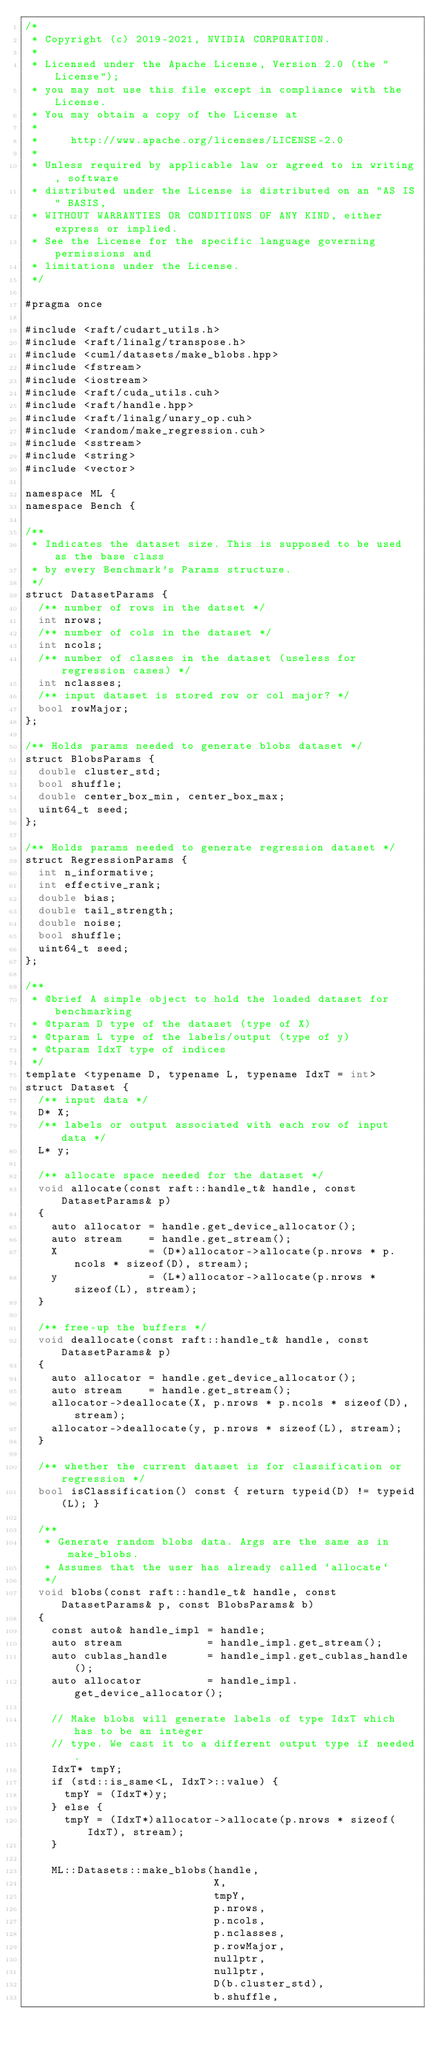Convert code to text. <code><loc_0><loc_0><loc_500><loc_500><_Cuda_>/*
 * Copyright (c) 2019-2021, NVIDIA CORPORATION.
 *
 * Licensed under the Apache License, Version 2.0 (the "License");
 * you may not use this file except in compliance with the License.
 * You may obtain a copy of the License at
 *
 *     http://www.apache.org/licenses/LICENSE-2.0
 *
 * Unless required by applicable law or agreed to in writing, software
 * distributed under the License is distributed on an "AS IS" BASIS,
 * WITHOUT WARRANTIES OR CONDITIONS OF ANY KIND, either express or implied.
 * See the License for the specific language governing permissions and
 * limitations under the License.
 */

#pragma once

#include <raft/cudart_utils.h>
#include <raft/linalg/transpose.h>
#include <cuml/datasets/make_blobs.hpp>
#include <fstream>
#include <iostream>
#include <raft/cuda_utils.cuh>
#include <raft/handle.hpp>
#include <raft/linalg/unary_op.cuh>
#include <random/make_regression.cuh>
#include <sstream>
#include <string>
#include <vector>

namespace ML {
namespace Bench {

/**
 * Indicates the dataset size. This is supposed to be used as the base class
 * by every Benchmark's Params structure.
 */
struct DatasetParams {
  /** number of rows in the datset */
  int nrows;
  /** number of cols in the dataset */
  int ncols;
  /** number of classes in the dataset (useless for regression cases) */
  int nclasses;
  /** input dataset is stored row or col major? */
  bool rowMajor;
};

/** Holds params needed to generate blobs dataset */
struct BlobsParams {
  double cluster_std;
  bool shuffle;
  double center_box_min, center_box_max;
  uint64_t seed;
};

/** Holds params needed to generate regression dataset */
struct RegressionParams {
  int n_informative;
  int effective_rank;
  double bias;
  double tail_strength;
  double noise;
  bool shuffle;
  uint64_t seed;
};

/**
 * @brief A simple object to hold the loaded dataset for benchmarking
 * @tparam D type of the dataset (type of X)
 * @tparam L type of the labels/output (type of y)
 * @tparam IdxT type of indices
 */
template <typename D, typename L, typename IdxT = int>
struct Dataset {
  /** input data */
  D* X;
  /** labels or output associated with each row of input data */
  L* y;

  /** allocate space needed for the dataset */
  void allocate(const raft::handle_t& handle, const DatasetParams& p)
  {
    auto allocator = handle.get_device_allocator();
    auto stream    = handle.get_stream();
    X              = (D*)allocator->allocate(p.nrows * p.ncols * sizeof(D), stream);
    y              = (L*)allocator->allocate(p.nrows * sizeof(L), stream);
  }

  /** free-up the buffers */
  void deallocate(const raft::handle_t& handle, const DatasetParams& p)
  {
    auto allocator = handle.get_device_allocator();
    auto stream    = handle.get_stream();
    allocator->deallocate(X, p.nrows * p.ncols * sizeof(D), stream);
    allocator->deallocate(y, p.nrows * sizeof(L), stream);
  }

  /** whether the current dataset is for classification or regression */
  bool isClassification() const { return typeid(D) != typeid(L); }

  /**
   * Generate random blobs data. Args are the same as in make_blobs.
   * Assumes that the user has already called `allocate`
   */
  void blobs(const raft::handle_t& handle, const DatasetParams& p, const BlobsParams& b)
  {
    const auto& handle_impl = handle;
    auto stream             = handle_impl.get_stream();
    auto cublas_handle      = handle_impl.get_cublas_handle();
    auto allocator          = handle_impl.get_device_allocator();

    // Make blobs will generate labels of type IdxT which has to be an integer
    // type. We cast it to a different output type if needed.
    IdxT* tmpY;
    if (std::is_same<L, IdxT>::value) {
      tmpY = (IdxT*)y;
    } else {
      tmpY = (IdxT*)allocator->allocate(p.nrows * sizeof(IdxT), stream);
    }

    ML::Datasets::make_blobs(handle,
                             X,
                             tmpY,
                             p.nrows,
                             p.ncols,
                             p.nclasses,
                             p.rowMajor,
                             nullptr,
                             nullptr,
                             D(b.cluster_std),
                             b.shuffle,</code> 